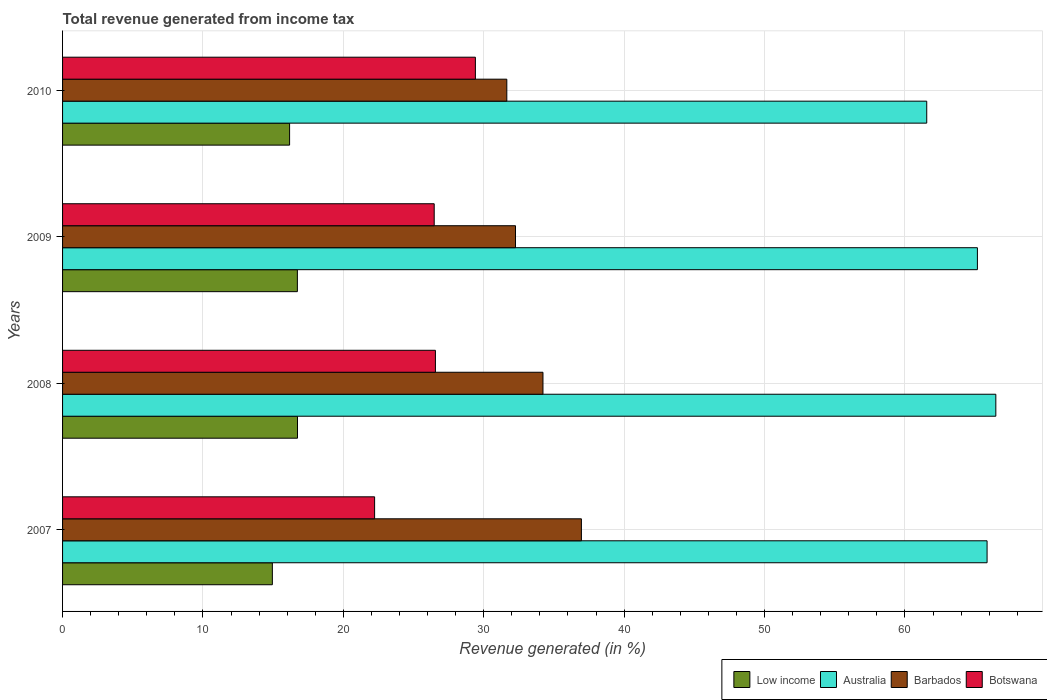How many different coloured bars are there?
Provide a succinct answer. 4. How many bars are there on the 4th tick from the bottom?
Offer a terse response. 4. What is the total revenue generated in Low income in 2007?
Keep it short and to the point. 14.94. Across all years, what is the maximum total revenue generated in Botswana?
Provide a short and direct response. 29.4. Across all years, what is the minimum total revenue generated in Barbados?
Ensure brevity in your answer.  31.64. In which year was the total revenue generated in Australia minimum?
Give a very brief answer. 2010. What is the total total revenue generated in Australia in the graph?
Ensure brevity in your answer.  259.04. What is the difference between the total revenue generated in Australia in 2008 and that in 2009?
Your response must be concise. 1.31. What is the difference between the total revenue generated in Botswana in 2009 and the total revenue generated in Barbados in 2008?
Ensure brevity in your answer.  -7.75. What is the average total revenue generated in Barbados per year?
Make the answer very short. 33.77. In the year 2009, what is the difference between the total revenue generated in Low income and total revenue generated in Botswana?
Make the answer very short. -9.75. What is the ratio of the total revenue generated in Botswana in 2007 to that in 2009?
Offer a terse response. 0.84. Is the difference between the total revenue generated in Low income in 2007 and 2010 greater than the difference between the total revenue generated in Botswana in 2007 and 2010?
Provide a short and direct response. Yes. What is the difference between the highest and the second highest total revenue generated in Botswana?
Give a very brief answer. 2.85. What is the difference between the highest and the lowest total revenue generated in Australia?
Provide a short and direct response. 4.92. In how many years, is the total revenue generated in Australia greater than the average total revenue generated in Australia taken over all years?
Offer a very short reply. 3. Is the sum of the total revenue generated in Australia in 2007 and 2010 greater than the maximum total revenue generated in Low income across all years?
Provide a succinct answer. Yes. Is it the case that in every year, the sum of the total revenue generated in Australia and total revenue generated in Barbados is greater than the sum of total revenue generated in Botswana and total revenue generated in Low income?
Provide a succinct answer. Yes. What does the 2nd bar from the top in 2008 represents?
Your answer should be very brief. Barbados. What does the 3rd bar from the bottom in 2009 represents?
Offer a very short reply. Barbados. What is the difference between two consecutive major ticks on the X-axis?
Offer a terse response. 10. Are the values on the major ticks of X-axis written in scientific E-notation?
Your response must be concise. No. Does the graph contain any zero values?
Give a very brief answer. No. Does the graph contain grids?
Your answer should be very brief. Yes. How many legend labels are there?
Provide a short and direct response. 4. What is the title of the graph?
Ensure brevity in your answer.  Total revenue generated from income tax. What is the label or title of the X-axis?
Your answer should be compact. Revenue generated (in %). What is the label or title of the Y-axis?
Your answer should be very brief. Years. What is the Revenue generated (in %) of Low income in 2007?
Your answer should be compact. 14.94. What is the Revenue generated (in %) in Australia in 2007?
Your answer should be compact. 65.85. What is the Revenue generated (in %) of Barbados in 2007?
Ensure brevity in your answer.  36.96. What is the Revenue generated (in %) in Botswana in 2007?
Provide a succinct answer. 22.23. What is the Revenue generated (in %) of Low income in 2008?
Offer a terse response. 16.73. What is the Revenue generated (in %) of Australia in 2008?
Ensure brevity in your answer.  66.48. What is the Revenue generated (in %) of Barbados in 2008?
Keep it short and to the point. 34.22. What is the Revenue generated (in %) in Botswana in 2008?
Your answer should be very brief. 26.56. What is the Revenue generated (in %) in Low income in 2009?
Provide a short and direct response. 16.73. What is the Revenue generated (in %) in Australia in 2009?
Make the answer very short. 65.16. What is the Revenue generated (in %) of Barbados in 2009?
Provide a succinct answer. 32.26. What is the Revenue generated (in %) in Botswana in 2009?
Offer a very short reply. 26.47. What is the Revenue generated (in %) in Low income in 2010?
Offer a very short reply. 16.17. What is the Revenue generated (in %) of Australia in 2010?
Make the answer very short. 61.55. What is the Revenue generated (in %) in Barbados in 2010?
Your answer should be compact. 31.64. What is the Revenue generated (in %) of Botswana in 2010?
Offer a very short reply. 29.4. Across all years, what is the maximum Revenue generated (in %) in Low income?
Provide a short and direct response. 16.73. Across all years, what is the maximum Revenue generated (in %) of Australia?
Your response must be concise. 66.48. Across all years, what is the maximum Revenue generated (in %) of Barbados?
Your answer should be compact. 36.96. Across all years, what is the maximum Revenue generated (in %) in Botswana?
Offer a terse response. 29.4. Across all years, what is the minimum Revenue generated (in %) in Low income?
Offer a terse response. 14.94. Across all years, what is the minimum Revenue generated (in %) of Australia?
Offer a very short reply. 61.55. Across all years, what is the minimum Revenue generated (in %) of Barbados?
Offer a terse response. 31.64. Across all years, what is the minimum Revenue generated (in %) in Botswana?
Keep it short and to the point. 22.23. What is the total Revenue generated (in %) in Low income in the graph?
Offer a very short reply. 64.57. What is the total Revenue generated (in %) in Australia in the graph?
Give a very brief answer. 259.04. What is the total Revenue generated (in %) of Barbados in the graph?
Your response must be concise. 135.08. What is the total Revenue generated (in %) in Botswana in the graph?
Your answer should be very brief. 104.66. What is the difference between the Revenue generated (in %) of Low income in 2007 and that in 2008?
Provide a short and direct response. -1.79. What is the difference between the Revenue generated (in %) in Australia in 2007 and that in 2008?
Ensure brevity in your answer.  -0.62. What is the difference between the Revenue generated (in %) in Barbados in 2007 and that in 2008?
Offer a very short reply. 2.74. What is the difference between the Revenue generated (in %) of Botswana in 2007 and that in 2008?
Your answer should be compact. -4.33. What is the difference between the Revenue generated (in %) of Low income in 2007 and that in 2009?
Your answer should be compact. -1.78. What is the difference between the Revenue generated (in %) of Australia in 2007 and that in 2009?
Keep it short and to the point. 0.69. What is the difference between the Revenue generated (in %) in Barbados in 2007 and that in 2009?
Ensure brevity in your answer.  4.69. What is the difference between the Revenue generated (in %) of Botswana in 2007 and that in 2009?
Keep it short and to the point. -4.25. What is the difference between the Revenue generated (in %) of Low income in 2007 and that in 2010?
Your answer should be very brief. -1.23. What is the difference between the Revenue generated (in %) in Australia in 2007 and that in 2010?
Provide a succinct answer. 4.3. What is the difference between the Revenue generated (in %) in Barbados in 2007 and that in 2010?
Keep it short and to the point. 5.31. What is the difference between the Revenue generated (in %) of Botswana in 2007 and that in 2010?
Keep it short and to the point. -7.18. What is the difference between the Revenue generated (in %) of Low income in 2008 and that in 2009?
Offer a terse response. 0.01. What is the difference between the Revenue generated (in %) in Australia in 2008 and that in 2009?
Ensure brevity in your answer.  1.31. What is the difference between the Revenue generated (in %) of Barbados in 2008 and that in 2009?
Offer a very short reply. 1.96. What is the difference between the Revenue generated (in %) of Botswana in 2008 and that in 2009?
Provide a short and direct response. 0.09. What is the difference between the Revenue generated (in %) of Low income in 2008 and that in 2010?
Give a very brief answer. 0.56. What is the difference between the Revenue generated (in %) in Australia in 2008 and that in 2010?
Ensure brevity in your answer.  4.92. What is the difference between the Revenue generated (in %) in Barbados in 2008 and that in 2010?
Make the answer very short. 2.58. What is the difference between the Revenue generated (in %) in Botswana in 2008 and that in 2010?
Offer a very short reply. -2.85. What is the difference between the Revenue generated (in %) in Low income in 2009 and that in 2010?
Offer a very short reply. 0.55. What is the difference between the Revenue generated (in %) in Australia in 2009 and that in 2010?
Your response must be concise. 3.61. What is the difference between the Revenue generated (in %) in Barbados in 2009 and that in 2010?
Give a very brief answer. 0.62. What is the difference between the Revenue generated (in %) in Botswana in 2009 and that in 2010?
Your answer should be very brief. -2.93. What is the difference between the Revenue generated (in %) of Low income in 2007 and the Revenue generated (in %) of Australia in 2008?
Give a very brief answer. -51.53. What is the difference between the Revenue generated (in %) of Low income in 2007 and the Revenue generated (in %) of Barbados in 2008?
Your response must be concise. -19.28. What is the difference between the Revenue generated (in %) of Low income in 2007 and the Revenue generated (in %) of Botswana in 2008?
Ensure brevity in your answer.  -11.61. What is the difference between the Revenue generated (in %) in Australia in 2007 and the Revenue generated (in %) in Barbados in 2008?
Offer a terse response. 31.63. What is the difference between the Revenue generated (in %) in Australia in 2007 and the Revenue generated (in %) in Botswana in 2008?
Your answer should be compact. 39.29. What is the difference between the Revenue generated (in %) of Barbados in 2007 and the Revenue generated (in %) of Botswana in 2008?
Your response must be concise. 10.4. What is the difference between the Revenue generated (in %) in Low income in 2007 and the Revenue generated (in %) in Australia in 2009?
Offer a terse response. -50.22. What is the difference between the Revenue generated (in %) in Low income in 2007 and the Revenue generated (in %) in Barbados in 2009?
Ensure brevity in your answer.  -17.32. What is the difference between the Revenue generated (in %) in Low income in 2007 and the Revenue generated (in %) in Botswana in 2009?
Your answer should be compact. -11.53. What is the difference between the Revenue generated (in %) in Australia in 2007 and the Revenue generated (in %) in Barbados in 2009?
Your answer should be very brief. 33.59. What is the difference between the Revenue generated (in %) of Australia in 2007 and the Revenue generated (in %) of Botswana in 2009?
Provide a succinct answer. 39.38. What is the difference between the Revenue generated (in %) in Barbados in 2007 and the Revenue generated (in %) in Botswana in 2009?
Provide a succinct answer. 10.49. What is the difference between the Revenue generated (in %) in Low income in 2007 and the Revenue generated (in %) in Australia in 2010?
Offer a terse response. -46.61. What is the difference between the Revenue generated (in %) in Low income in 2007 and the Revenue generated (in %) in Barbados in 2010?
Your answer should be compact. -16.7. What is the difference between the Revenue generated (in %) of Low income in 2007 and the Revenue generated (in %) of Botswana in 2010?
Your response must be concise. -14.46. What is the difference between the Revenue generated (in %) of Australia in 2007 and the Revenue generated (in %) of Barbados in 2010?
Offer a terse response. 34.21. What is the difference between the Revenue generated (in %) in Australia in 2007 and the Revenue generated (in %) in Botswana in 2010?
Your answer should be very brief. 36.45. What is the difference between the Revenue generated (in %) in Barbados in 2007 and the Revenue generated (in %) in Botswana in 2010?
Your answer should be very brief. 7.55. What is the difference between the Revenue generated (in %) in Low income in 2008 and the Revenue generated (in %) in Australia in 2009?
Offer a terse response. -48.43. What is the difference between the Revenue generated (in %) of Low income in 2008 and the Revenue generated (in %) of Barbados in 2009?
Give a very brief answer. -15.53. What is the difference between the Revenue generated (in %) of Low income in 2008 and the Revenue generated (in %) of Botswana in 2009?
Offer a very short reply. -9.74. What is the difference between the Revenue generated (in %) of Australia in 2008 and the Revenue generated (in %) of Barbados in 2009?
Give a very brief answer. 34.21. What is the difference between the Revenue generated (in %) of Australia in 2008 and the Revenue generated (in %) of Botswana in 2009?
Offer a terse response. 40. What is the difference between the Revenue generated (in %) of Barbados in 2008 and the Revenue generated (in %) of Botswana in 2009?
Provide a succinct answer. 7.75. What is the difference between the Revenue generated (in %) in Low income in 2008 and the Revenue generated (in %) in Australia in 2010?
Keep it short and to the point. -44.82. What is the difference between the Revenue generated (in %) of Low income in 2008 and the Revenue generated (in %) of Barbados in 2010?
Provide a short and direct response. -14.91. What is the difference between the Revenue generated (in %) in Low income in 2008 and the Revenue generated (in %) in Botswana in 2010?
Keep it short and to the point. -12.67. What is the difference between the Revenue generated (in %) of Australia in 2008 and the Revenue generated (in %) of Barbados in 2010?
Keep it short and to the point. 34.83. What is the difference between the Revenue generated (in %) of Australia in 2008 and the Revenue generated (in %) of Botswana in 2010?
Provide a succinct answer. 37.07. What is the difference between the Revenue generated (in %) in Barbados in 2008 and the Revenue generated (in %) in Botswana in 2010?
Your answer should be very brief. 4.81. What is the difference between the Revenue generated (in %) in Low income in 2009 and the Revenue generated (in %) in Australia in 2010?
Offer a terse response. -44.83. What is the difference between the Revenue generated (in %) of Low income in 2009 and the Revenue generated (in %) of Barbados in 2010?
Your answer should be very brief. -14.92. What is the difference between the Revenue generated (in %) in Low income in 2009 and the Revenue generated (in %) in Botswana in 2010?
Provide a succinct answer. -12.68. What is the difference between the Revenue generated (in %) of Australia in 2009 and the Revenue generated (in %) of Barbados in 2010?
Make the answer very short. 33.52. What is the difference between the Revenue generated (in %) of Australia in 2009 and the Revenue generated (in %) of Botswana in 2010?
Provide a succinct answer. 35.76. What is the difference between the Revenue generated (in %) in Barbados in 2009 and the Revenue generated (in %) in Botswana in 2010?
Your answer should be very brief. 2.86. What is the average Revenue generated (in %) in Low income per year?
Offer a terse response. 16.14. What is the average Revenue generated (in %) of Australia per year?
Your answer should be compact. 64.76. What is the average Revenue generated (in %) in Barbados per year?
Your answer should be compact. 33.77. What is the average Revenue generated (in %) of Botswana per year?
Make the answer very short. 26.16. In the year 2007, what is the difference between the Revenue generated (in %) of Low income and Revenue generated (in %) of Australia?
Your answer should be very brief. -50.91. In the year 2007, what is the difference between the Revenue generated (in %) of Low income and Revenue generated (in %) of Barbados?
Your response must be concise. -22.01. In the year 2007, what is the difference between the Revenue generated (in %) of Low income and Revenue generated (in %) of Botswana?
Offer a very short reply. -7.28. In the year 2007, what is the difference between the Revenue generated (in %) of Australia and Revenue generated (in %) of Barbados?
Make the answer very short. 28.9. In the year 2007, what is the difference between the Revenue generated (in %) of Australia and Revenue generated (in %) of Botswana?
Provide a short and direct response. 43.63. In the year 2007, what is the difference between the Revenue generated (in %) of Barbados and Revenue generated (in %) of Botswana?
Give a very brief answer. 14.73. In the year 2008, what is the difference between the Revenue generated (in %) in Low income and Revenue generated (in %) in Australia?
Ensure brevity in your answer.  -49.74. In the year 2008, what is the difference between the Revenue generated (in %) of Low income and Revenue generated (in %) of Barbados?
Keep it short and to the point. -17.48. In the year 2008, what is the difference between the Revenue generated (in %) in Low income and Revenue generated (in %) in Botswana?
Give a very brief answer. -9.82. In the year 2008, what is the difference between the Revenue generated (in %) in Australia and Revenue generated (in %) in Barbados?
Provide a succinct answer. 32.26. In the year 2008, what is the difference between the Revenue generated (in %) in Australia and Revenue generated (in %) in Botswana?
Your response must be concise. 39.92. In the year 2008, what is the difference between the Revenue generated (in %) of Barbados and Revenue generated (in %) of Botswana?
Your answer should be very brief. 7.66. In the year 2009, what is the difference between the Revenue generated (in %) of Low income and Revenue generated (in %) of Australia?
Give a very brief answer. -48.44. In the year 2009, what is the difference between the Revenue generated (in %) in Low income and Revenue generated (in %) in Barbados?
Offer a terse response. -15.54. In the year 2009, what is the difference between the Revenue generated (in %) of Low income and Revenue generated (in %) of Botswana?
Your answer should be very brief. -9.75. In the year 2009, what is the difference between the Revenue generated (in %) of Australia and Revenue generated (in %) of Barbados?
Your answer should be compact. 32.9. In the year 2009, what is the difference between the Revenue generated (in %) in Australia and Revenue generated (in %) in Botswana?
Keep it short and to the point. 38.69. In the year 2009, what is the difference between the Revenue generated (in %) of Barbados and Revenue generated (in %) of Botswana?
Give a very brief answer. 5.79. In the year 2010, what is the difference between the Revenue generated (in %) in Low income and Revenue generated (in %) in Australia?
Your answer should be very brief. -45.38. In the year 2010, what is the difference between the Revenue generated (in %) in Low income and Revenue generated (in %) in Barbados?
Provide a succinct answer. -15.47. In the year 2010, what is the difference between the Revenue generated (in %) in Low income and Revenue generated (in %) in Botswana?
Your response must be concise. -13.23. In the year 2010, what is the difference between the Revenue generated (in %) in Australia and Revenue generated (in %) in Barbados?
Ensure brevity in your answer.  29.91. In the year 2010, what is the difference between the Revenue generated (in %) in Australia and Revenue generated (in %) in Botswana?
Your answer should be compact. 32.15. In the year 2010, what is the difference between the Revenue generated (in %) in Barbados and Revenue generated (in %) in Botswana?
Offer a very short reply. 2.24. What is the ratio of the Revenue generated (in %) of Low income in 2007 to that in 2008?
Keep it short and to the point. 0.89. What is the ratio of the Revenue generated (in %) in Australia in 2007 to that in 2008?
Your answer should be very brief. 0.99. What is the ratio of the Revenue generated (in %) in Botswana in 2007 to that in 2008?
Keep it short and to the point. 0.84. What is the ratio of the Revenue generated (in %) in Low income in 2007 to that in 2009?
Your answer should be compact. 0.89. What is the ratio of the Revenue generated (in %) in Australia in 2007 to that in 2009?
Your answer should be very brief. 1.01. What is the ratio of the Revenue generated (in %) in Barbados in 2007 to that in 2009?
Keep it short and to the point. 1.15. What is the ratio of the Revenue generated (in %) of Botswana in 2007 to that in 2009?
Your answer should be compact. 0.84. What is the ratio of the Revenue generated (in %) of Low income in 2007 to that in 2010?
Your answer should be very brief. 0.92. What is the ratio of the Revenue generated (in %) in Australia in 2007 to that in 2010?
Your answer should be compact. 1.07. What is the ratio of the Revenue generated (in %) of Barbados in 2007 to that in 2010?
Ensure brevity in your answer.  1.17. What is the ratio of the Revenue generated (in %) of Botswana in 2007 to that in 2010?
Your response must be concise. 0.76. What is the ratio of the Revenue generated (in %) of Australia in 2008 to that in 2009?
Ensure brevity in your answer.  1.02. What is the ratio of the Revenue generated (in %) in Barbados in 2008 to that in 2009?
Keep it short and to the point. 1.06. What is the ratio of the Revenue generated (in %) of Botswana in 2008 to that in 2009?
Provide a succinct answer. 1. What is the ratio of the Revenue generated (in %) of Low income in 2008 to that in 2010?
Give a very brief answer. 1.03. What is the ratio of the Revenue generated (in %) in Australia in 2008 to that in 2010?
Make the answer very short. 1.08. What is the ratio of the Revenue generated (in %) in Barbados in 2008 to that in 2010?
Your answer should be compact. 1.08. What is the ratio of the Revenue generated (in %) of Botswana in 2008 to that in 2010?
Your answer should be very brief. 0.9. What is the ratio of the Revenue generated (in %) in Low income in 2009 to that in 2010?
Offer a very short reply. 1.03. What is the ratio of the Revenue generated (in %) of Australia in 2009 to that in 2010?
Give a very brief answer. 1.06. What is the ratio of the Revenue generated (in %) in Barbados in 2009 to that in 2010?
Your response must be concise. 1.02. What is the ratio of the Revenue generated (in %) of Botswana in 2009 to that in 2010?
Provide a succinct answer. 0.9. What is the difference between the highest and the second highest Revenue generated (in %) of Low income?
Keep it short and to the point. 0.01. What is the difference between the highest and the second highest Revenue generated (in %) in Australia?
Keep it short and to the point. 0.62. What is the difference between the highest and the second highest Revenue generated (in %) in Barbados?
Provide a succinct answer. 2.74. What is the difference between the highest and the second highest Revenue generated (in %) in Botswana?
Keep it short and to the point. 2.85. What is the difference between the highest and the lowest Revenue generated (in %) in Low income?
Your answer should be very brief. 1.79. What is the difference between the highest and the lowest Revenue generated (in %) in Australia?
Your response must be concise. 4.92. What is the difference between the highest and the lowest Revenue generated (in %) of Barbados?
Offer a very short reply. 5.31. What is the difference between the highest and the lowest Revenue generated (in %) of Botswana?
Ensure brevity in your answer.  7.18. 